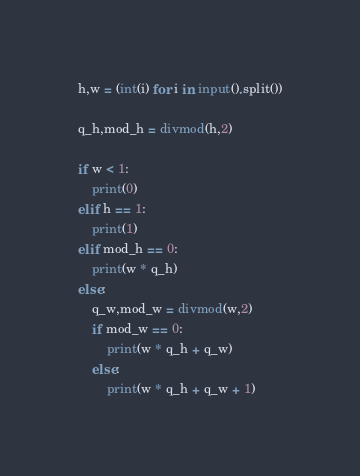Convert code to text. <code><loc_0><loc_0><loc_500><loc_500><_Python_>h,w = (int(i) for i in input().split())

q_h,mod_h = divmod(h,2)

if w < 1:
	print(0)
elif h == 1:
	print(1)
elif mod_h == 0: 	
	print(w * q_h)
else:
	q_w,mod_w = divmod(w,2)
	if mod_w == 0:
		print(w * q_h + q_w)
	else:
		print(w * q_h + q_w + 1)</code> 